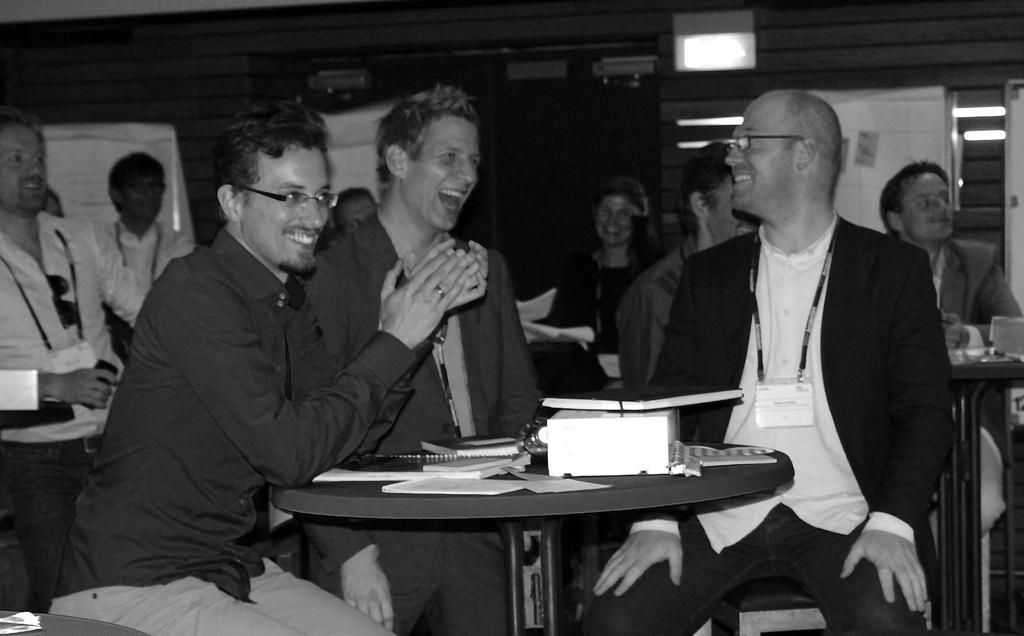What are the people in the image doing? The people in the image are sitting on chairs. What is the main piece of furniture in the image? There is a table in the image. What items can be found on the table? There are tissues, papers, and books on the table. What shape are the fairies flying in the image? There are no fairies present in the image. 